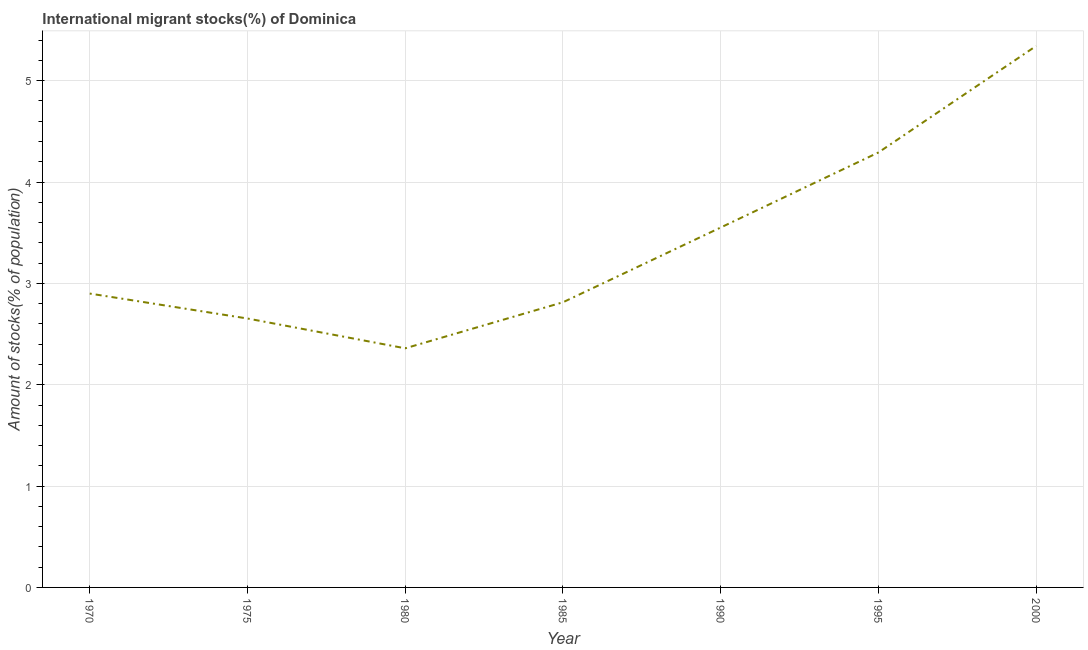What is the number of international migrant stocks in 2000?
Ensure brevity in your answer.  5.34. Across all years, what is the maximum number of international migrant stocks?
Offer a terse response. 5.34. Across all years, what is the minimum number of international migrant stocks?
Ensure brevity in your answer.  2.36. In which year was the number of international migrant stocks minimum?
Give a very brief answer. 1980. What is the sum of the number of international migrant stocks?
Provide a succinct answer. 23.91. What is the difference between the number of international migrant stocks in 1970 and 2000?
Provide a short and direct response. -2.44. What is the average number of international migrant stocks per year?
Offer a terse response. 3.42. What is the median number of international migrant stocks?
Keep it short and to the point. 2.9. In how many years, is the number of international migrant stocks greater than 2 %?
Your response must be concise. 7. What is the ratio of the number of international migrant stocks in 1975 to that in 1980?
Give a very brief answer. 1.12. Is the difference between the number of international migrant stocks in 1980 and 2000 greater than the difference between any two years?
Offer a terse response. Yes. What is the difference between the highest and the second highest number of international migrant stocks?
Give a very brief answer. 1.05. What is the difference between the highest and the lowest number of international migrant stocks?
Give a very brief answer. 2.98. In how many years, is the number of international migrant stocks greater than the average number of international migrant stocks taken over all years?
Your answer should be compact. 3. Does the number of international migrant stocks monotonically increase over the years?
Offer a terse response. No. How many lines are there?
Your answer should be very brief. 1. How many years are there in the graph?
Offer a terse response. 7. What is the difference between two consecutive major ticks on the Y-axis?
Provide a succinct answer. 1. Are the values on the major ticks of Y-axis written in scientific E-notation?
Provide a succinct answer. No. What is the title of the graph?
Provide a succinct answer. International migrant stocks(%) of Dominica. What is the label or title of the X-axis?
Your response must be concise. Year. What is the label or title of the Y-axis?
Your answer should be compact. Amount of stocks(% of population). What is the Amount of stocks(% of population) in 1970?
Keep it short and to the point. 2.9. What is the Amount of stocks(% of population) in 1975?
Make the answer very short. 2.65. What is the Amount of stocks(% of population) in 1980?
Make the answer very short. 2.36. What is the Amount of stocks(% of population) of 1985?
Your answer should be very brief. 2.81. What is the Amount of stocks(% of population) in 1990?
Provide a short and direct response. 3.55. What is the Amount of stocks(% of population) of 1995?
Provide a succinct answer. 4.29. What is the Amount of stocks(% of population) in 2000?
Give a very brief answer. 5.34. What is the difference between the Amount of stocks(% of population) in 1970 and 1975?
Offer a terse response. 0.25. What is the difference between the Amount of stocks(% of population) in 1970 and 1980?
Ensure brevity in your answer.  0.54. What is the difference between the Amount of stocks(% of population) in 1970 and 1985?
Your answer should be compact. 0.09. What is the difference between the Amount of stocks(% of population) in 1970 and 1990?
Offer a terse response. -0.65. What is the difference between the Amount of stocks(% of population) in 1970 and 1995?
Offer a very short reply. -1.39. What is the difference between the Amount of stocks(% of population) in 1970 and 2000?
Give a very brief answer. -2.44. What is the difference between the Amount of stocks(% of population) in 1975 and 1980?
Your answer should be compact. 0.29. What is the difference between the Amount of stocks(% of population) in 1975 and 1985?
Ensure brevity in your answer.  -0.16. What is the difference between the Amount of stocks(% of population) in 1975 and 1990?
Give a very brief answer. -0.9. What is the difference between the Amount of stocks(% of population) in 1975 and 1995?
Make the answer very short. -1.64. What is the difference between the Amount of stocks(% of population) in 1975 and 2000?
Your response must be concise. -2.69. What is the difference between the Amount of stocks(% of population) in 1980 and 1985?
Provide a succinct answer. -0.45. What is the difference between the Amount of stocks(% of population) in 1980 and 1990?
Your answer should be very brief. -1.19. What is the difference between the Amount of stocks(% of population) in 1980 and 1995?
Give a very brief answer. -1.93. What is the difference between the Amount of stocks(% of population) in 1980 and 2000?
Make the answer very short. -2.98. What is the difference between the Amount of stocks(% of population) in 1985 and 1990?
Give a very brief answer. -0.74. What is the difference between the Amount of stocks(% of population) in 1985 and 1995?
Your answer should be compact. -1.48. What is the difference between the Amount of stocks(% of population) in 1985 and 2000?
Give a very brief answer. -2.53. What is the difference between the Amount of stocks(% of population) in 1990 and 1995?
Your response must be concise. -0.74. What is the difference between the Amount of stocks(% of population) in 1990 and 2000?
Keep it short and to the point. -1.79. What is the difference between the Amount of stocks(% of population) in 1995 and 2000?
Provide a short and direct response. -1.05. What is the ratio of the Amount of stocks(% of population) in 1970 to that in 1975?
Offer a terse response. 1.09. What is the ratio of the Amount of stocks(% of population) in 1970 to that in 1980?
Your response must be concise. 1.23. What is the ratio of the Amount of stocks(% of population) in 1970 to that in 1985?
Your answer should be compact. 1.03. What is the ratio of the Amount of stocks(% of population) in 1970 to that in 1990?
Provide a short and direct response. 0.82. What is the ratio of the Amount of stocks(% of population) in 1970 to that in 1995?
Provide a short and direct response. 0.68. What is the ratio of the Amount of stocks(% of population) in 1970 to that in 2000?
Provide a short and direct response. 0.54. What is the ratio of the Amount of stocks(% of population) in 1975 to that in 1980?
Offer a terse response. 1.12. What is the ratio of the Amount of stocks(% of population) in 1975 to that in 1985?
Offer a terse response. 0.94. What is the ratio of the Amount of stocks(% of population) in 1975 to that in 1990?
Your answer should be compact. 0.75. What is the ratio of the Amount of stocks(% of population) in 1975 to that in 1995?
Offer a terse response. 0.62. What is the ratio of the Amount of stocks(% of population) in 1975 to that in 2000?
Your answer should be compact. 0.5. What is the ratio of the Amount of stocks(% of population) in 1980 to that in 1985?
Give a very brief answer. 0.84. What is the ratio of the Amount of stocks(% of population) in 1980 to that in 1990?
Your response must be concise. 0.66. What is the ratio of the Amount of stocks(% of population) in 1980 to that in 1995?
Provide a short and direct response. 0.55. What is the ratio of the Amount of stocks(% of population) in 1980 to that in 2000?
Offer a terse response. 0.44. What is the ratio of the Amount of stocks(% of population) in 1985 to that in 1990?
Make the answer very short. 0.79. What is the ratio of the Amount of stocks(% of population) in 1985 to that in 1995?
Ensure brevity in your answer.  0.66. What is the ratio of the Amount of stocks(% of population) in 1985 to that in 2000?
Your answer should be compact. 0.53. What is the ratio of the Amount of stocks(% of population) in 1990 to that in 1995?
Provide a succinct answer. 0.83. What is the ratio of the Amount of stocks(% of population) in 1990 to that in 2000?
Your answer should be very brief. 0.67. What is the ratio of the Amount of stocks(% of population) in 1995 to that in 2000?
Make the answer very short. 0.8. 